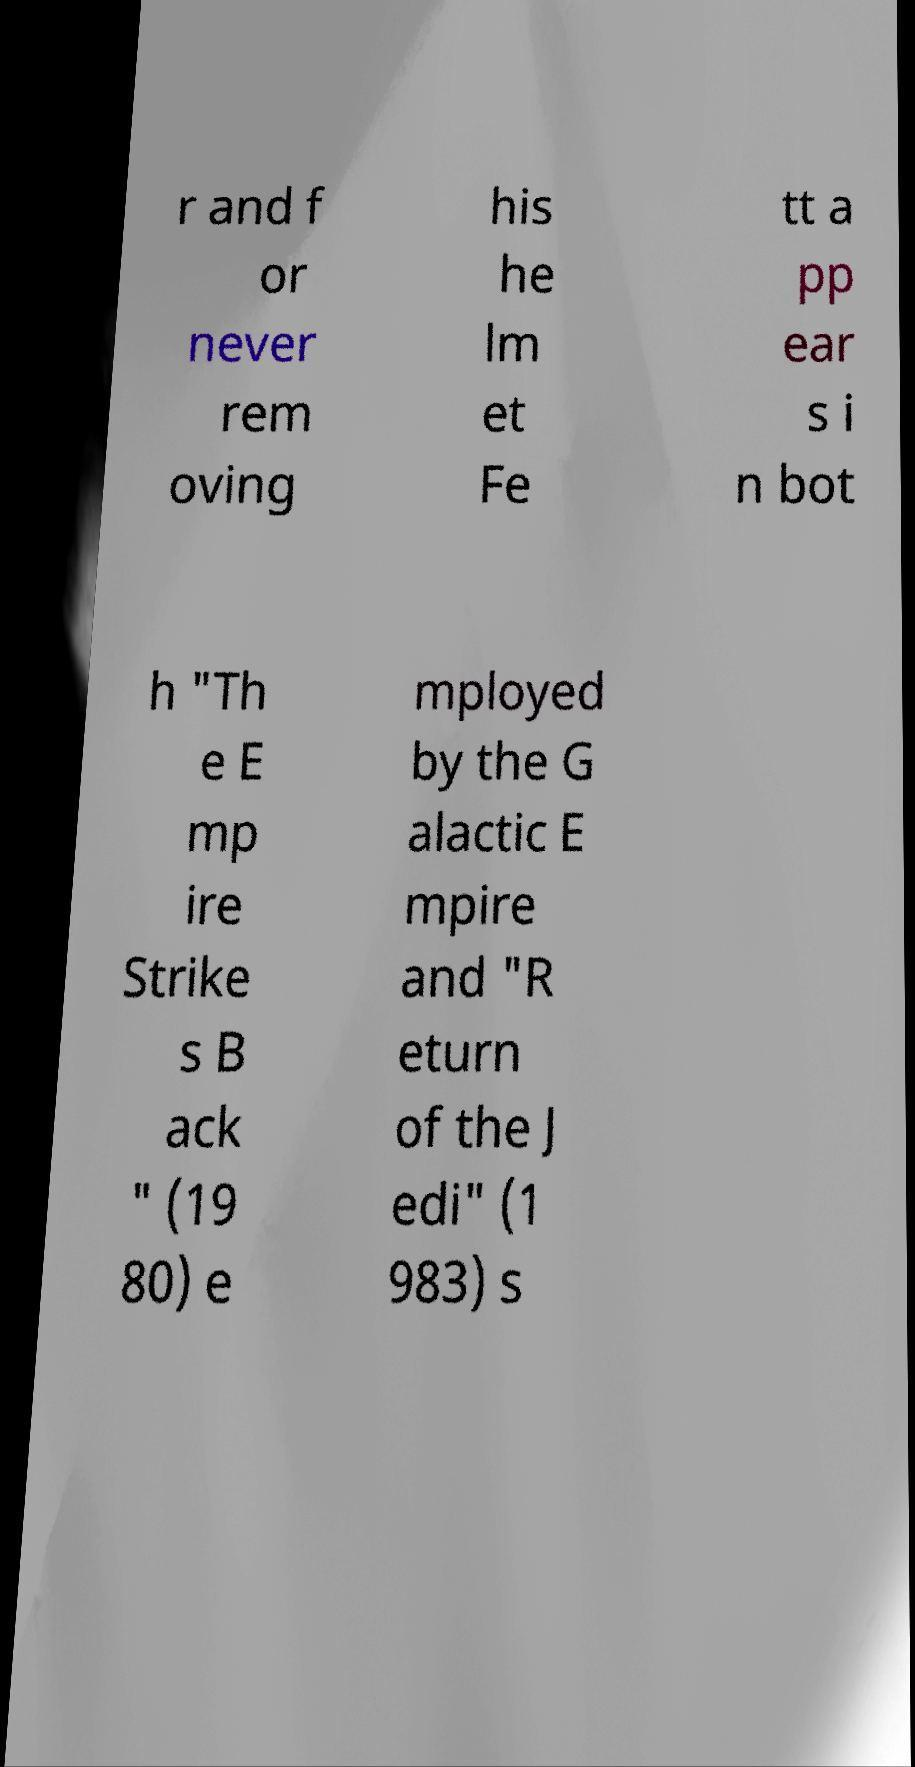Please read and relay the text visible in this image. What does it say? r and f or never rem oving his he lm et Fe tt a pp ear s i n bot h "Th e E mp ire Strike s B ack " (19 80) e mployed by the G alactic E mpire and "R eturn of the J edi" (1 983) s 